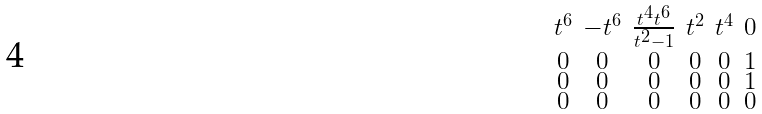Convert formula to latex. <formula><loc_0><loc_0><loc_500><loc_500>\begin{smallmatrix} t ^ { 6 } & - t ^ { 6 } & \frac { t ^ { 4 } t ^ { 6 } } { t ^ { 2 } - 1 } & t ^ { 2 } & t ^ { 4 } & 0 \\ 0 & 0 & 0 & 0 & 0 & 1 \\ 0 & 0 & 0 & 0 & 0 & 1 \\ 0 & 0 & 0 & 0 & 0 & 0 \end{smallmatrix}</formula> 